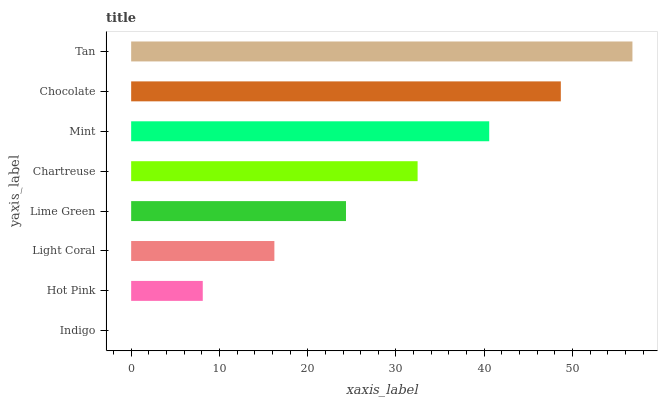Is Indigo the minimum?
Answer yes or no. Yes. Is Tan the maximum?
Answer yes or no. Yes. Is Hot Pink the minimum?
Answer yes or no. No. Is Hot Pink the maximum?
Answer yes or no. No. Is Hot Pink greater than Indigo?
Answer yes or no. Yes. Is Indigo less than Hot Pink?
Answer yes or no. Yes. Is Indigo greater than Hot Pink?
Answer yes or no. No. Is Hot Pink less than Indigo?
Answer yes or no. No. Is Chartreuse the high median?
Answer yes or no. Yes. Is Lime Green the low median?
Answer yes or no. Yes. Is Light Coral the high median?
Answer yes or no. No. Is Indigo the low median?
Answer yes or no. No. 